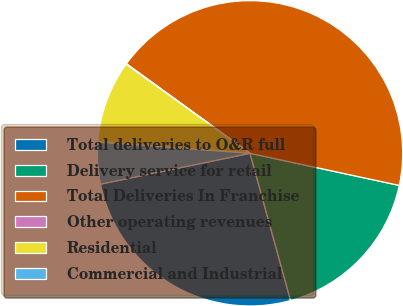Convert chart to OTSL. <chart><loc_0><loc_0><loc_500><loc_500><pie_chart><fcel>Total deliveries to O&R full<fcel>Delivery service for retail<fcel>Total Deliveries In Franchise<fcel>Other operating revenues<fcel>Residential<fcel>Commercial and Industrial<nl><fcel>26.04%<fcel>17.35%<fcel>43.39%<fcel>0.07%<fcel>8.74%<fcel>4.41%<nl></chart> 